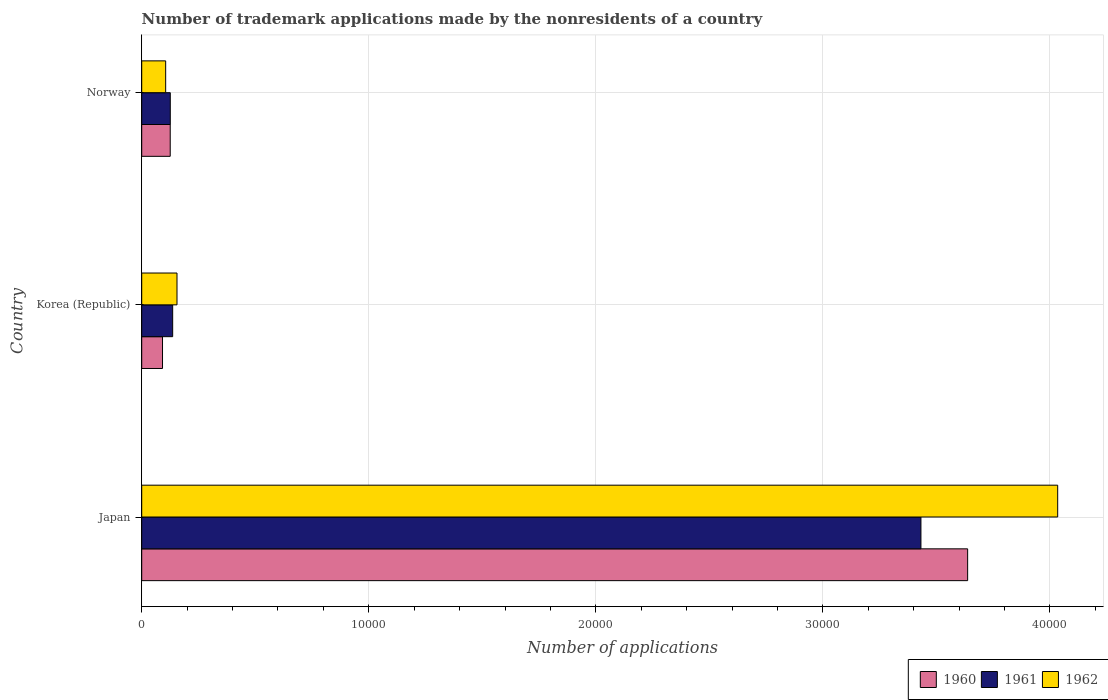How many groups of bars are there?
Provide a short and direct response. 3. Are the number of bars per tick equal to the number of legend labels?
Keep it short and to the point. Yes. In how many cases, is the number of bars for a given country not equal to the number of legend labels?
Offer a terse response. 0. What is the number of trademark applications made by the nonresidents in 1960 in Norway?
Your answer should be very brief. 1255. Across all countries, what is the maximum number of trademark applications made by the nonresidents in 1960?
Provide a succinct answer. 3.64e+04. Across all countries, what is the minimum number of trademark applications made by the nonresidents in 1961?
Your response must be concise. 1258. In which country was the number of trademark applications made by the nonresidents in 1960 maximum?
Give a very brief answer. Japan. What is the total number of trademark applications made by the nonresidents in 1961 in the graph?
Ensure brevity in your answer.  3.69e+04. What is the difference between the number of trademark applications made by the nonresidents in 1962 in Japan and that in Norway?
Ensure brevity in your answer.  3.93e+04. What is the difference between the number of trademark applications made by the nonresidents in 1960 in Japan and the number of trademark applications made by the nonresidents in 1962 in Korea (Republic)?
Provide a succinct answer. 3.48e+04. What is the average number of trademark applications made by the nonresidents in 1962 per country?
Offer a terse response. 1.43e+04. What is the difference between the number of trademark applications made by the nonresidents in 1960 and number of trademark applications made by the nonresidents in 1961 in Japan?
Keep it short and to the point. 2057. What is the ratio of the number of trademark applications made by the nonresidents in 1961 in Japan to that in Norway?
Make the answer very short. 27.28. Is the difference between the number of trademark applications made by the nonresidents in 1960 in Japan and Norway greater than the difference between the number of trademark applications made by the nonresidents in 1961 in Japan and Norway?
Your response must be concise. Yes. What is the difference between the highest and the second highest number of trademark applications made by the nonresidents in 1962?
Keep it short and to the point. 3.88e+04. What is the difference between the highest and the lowest number of trademark applications made by the nonresidents in 1960?
Provide a succinct answer. 3.55e+04. In how many countries, is the number of trademark applications made by the nonresidents in 1960 greater than the average number of trademark applications made by the nonresidents in 1960 taken over all countries?
Keep it short and to the point. 1. What does the 2nd bar from the top in Norway represents?
Provide a short and direct response. 1961. What does the 1st bar from the bottom in Japan represents?
Keep it short and to the point. 1960. Is it the case that in every country, the sum of the number of trademark applications made by the nonresidents in 1960 and number of trademark applications made by the nonresidents in 1961 is greater than the number of trademark applications made by the nonresidents in 1962?
Make the answer very short. Yes. Are the values on the major ticks of X-axis written in scientific E-notation?
Your answer should be very brief. No. Does the graph contain any zero values?
Your answer should be very brief. No. How are the legend labels stacked?
Your response must be concise. Horizontal. What is the title of the graph?
Your answer should be very brief. Number of trademark applications made by the nonresidents of a country. What is the label or title of the X-axis?
Provide a short and direct response. Number of applications. What is the Number of applications of 1960 in Japan?
Ensure brevity in your answer.  3.64e+04. What is the Number of applications of 1961 in Japan?
Offer a terse response. 3.43e+04. What is the Number of applications of 1962 in Japan?
Keep it short and to the point. 4.03e+04. What is the Number of applications of 1960 in Korea (Republic)?
Your answer should be compact. 916. What is the Number of applications of 1961 in Korea (Republic)?
Offer a very short reply. 1363. What is the Number of applications of 1962 in Korea (Republic)?
Your response must be concise. 1554. What is the Number of applications in 1960 in Norway?
Ensure brevity in your answer.  1255. What is the Number of applications in 1961 in Norway?
Your answer should be very brief. 1258. What is the Number of applications in 1962 in Norway?
Make the answer very short. 1055. Across all countries, what is the maximum Number of applications in 1960?
Make the answer very short. 3.64e+04. Across all countries, what is the maximum Number of applications of 1961?
Offer a very short reply. 3.43e+04. Across all countries, what is the maximum Number of applications in 1962?
Offer a very short reply. 4.03e+04. Across all countries, what is the minimum Number of applications in 1960?
Offer a terse response. 916. Across all countries, what is the minimum Number of applications of 1961?
Your answer should be compact. 1258. Across all countries, what is the minimum Number of applications in 1962?
Your answer should be compact. 1055. What is the total Number of applications in 1960 in the graph?
Your response must be concise. 3.85e+04. What is the total Number of applications in 1961 in the graph?
Provide a short and direct response. 3.69e+04. What is the total Number of applications in 1962 in the graph?
Provide a short and direct response. 4.30e+04. What is the difference between the Number of applications of 1960 in Japan and that in Korea (Republic)?
Make the answer very short. 3.55e+04. What is the difference between the Number of applications of 1961 in Japan and that in Korea (Republic)?
Provide a short and direct response. 3.30e+04. What is the difference between the Number of applications of 1962 in Japan and that in Korea (Republic)?
Keep it short and to the point. 3.88e+04. What is the difference between the Number of applications in 1960 in Japan and that in Norway?
Offer a very short reply. 3.51e+04. What is the difference between the Number of applications of 1961 in Japan and that in Norway?
Your answer should be compact. 3.31e+04. What is the difference between the Number of applications in 1962 in Japan and that in Norway?
Ensure brevity in your answer.  3.93e+04. What is the difference between the Number of applications in 1960 in Korea (Republic) and that in Norway?
Offer a very short reply. -339. What is the difference between the Number of applications of 1961 in Korea (Republic) and that in Norway?
Provide a short and direct response. 105. What is the difference between the Number of applications in 1962 in Korea (Republic) and that in Norway?
Your answer should be compact. 499. What is the difference between the Number of applications of 1960 in Japan and the Number of applications of 1961 in Korea (Republic)?
Give a very brief answer. 3.50e+04. What is the difference between the Number of applications in 1960 in Japan and the Number of applications in 1962 in Korea (Republic)?
Provide a succinct answer. 3.48e+04. What is the difference between the Number of applications in 1961 in Japan and the Number of applications in 1962 in Korea (Republic)?
Give a very brief answer. 3.28e+04. What is the difference between the Number of applications of 1960 in Japan and the Number of applications of 1961 in Norway?
Offer a terse response. 3.51e+04. What is the difference between the Number of applications of 1960 in Japan and the Number of applications of 1962 in Norway?
Your answer should be compact. 3.53e+04. What is the difference between the Number of applications of 1961 in Japan and the Number of applications of 1962 in Norway?
Offer a very short reply. 3.33e+04. What is the difference between the Number of applications in 1960 in Korea (Republic) and the Number of applications in 1961 in Norway?
Your answer should be compact. -342. What is the difference between the Number of applications of 1960 in Korea (Republic) and the Number of applications of 1962 in Norway?
Offer a terse response. -139. What is the difference between the Number of applications in 1961 in Korea (Republic) and the Number of applications in 1962 in Norway?
Your response must be concise. 308. What is the average Number of applications of 1960 per country?
Offer a terse response. 1.28e+04. What is the average Number of applications of 1961 per country?
Provide a short and direct response. 1.23e+04. What is the average Number of applications of 1962 per country?
Your answer should be very brief. 1.43e+04. What is the difference between the Number of applications of 1960 and Number of applications of 1961 in Japan?
Offer a terse response. 2057. What is the difference between the Number of applications of 1960 and Number of applications of 1962 in Japan?
Offer a terse response. -3966. What is the difference between the Number of applications in 1961 and Number of applications in 1962 in Japan?
Keep it short and to the point. -6023. What is the difference between the Number of applications of 1960 and Number of applications of 1961 in Korea (Republic)?
Your answer should be very brief. -447. What is the difference between the Number of applications in 1960 and Number of applications in 1962 in Korea (Republic)?
Provide a succinct answer. -638. What is the difference between the Number of applications in 1961 and Number of applications in 1962 in Korea (Republic)?
Keep it short and to the point. -191. What is the difference between the Number of applications of 1960 and Number of applications of 1962 in Norway?
Provide a succinct answer. 200. What is the difference between the Number of applications of 1961 and Number of applications of 1962 in Norway?
Offer a very short reply. 203. What is the ratio of the Number of applications in 1960 in Japan to that in Korea (Republic)?
Provide a succinct answer. 39.71. What is the ratio of the Number of applications in 1961 in Japan to that in Korea (Republic)?
Your response must be concise. 25.18. What is the ratio of the Number of applications in 1962 in Japan to that in Korea (Republic)?
Your answer should be compact. 25.96. What is the ratio of the Number of applications of 1960 in Japan to that in Norway?
Offer a very short reply. 28.99. What is the ratio of the Number of applications in 1961 in Japan to that in Norway?
Offer a terse response. 27.28. What is the ratio of the Number of applications in 1962 in Japan to that in Norway?
Ensure brevity in your answer.  38.24. What is the ratio of the Number of applications in 1960 in Korea (Republic) to that in Norway?
Keep it short and to the point. 0.73. What is the ratio of the Number of applications in 1961 in Korea (Republic) to that in Norway?
Provide a succinct answer. 1.08. What is the ratio of the Number of applications of 1962 in Korea (Republic) to that in Norway?
Provide a short and direct response. 1.47. What is the difference between the highest and the second highest Number of applications in 1960?
Keep it short and to the point. 3.51e+04. What is the difference between the highest and the second highest Number of applications of 1961?
Provide a succinct answer. 3.30e+04. What is the difference between the highest and the second highest Number of applications of 1962?
Give a very brief answer. 3.88e+04. What is the difference between the highest and the lowest Number of applications in 1960?
Provide a succinct answer. 3.55e+04. What is the difference between the highest and the lowest Number of applications of 1961?
Your answer should be very brief. 3.31e+04. What is the difference between the highest and the lowest Number of applications of 1962?
Your response must be concise. 3.93e+04. 